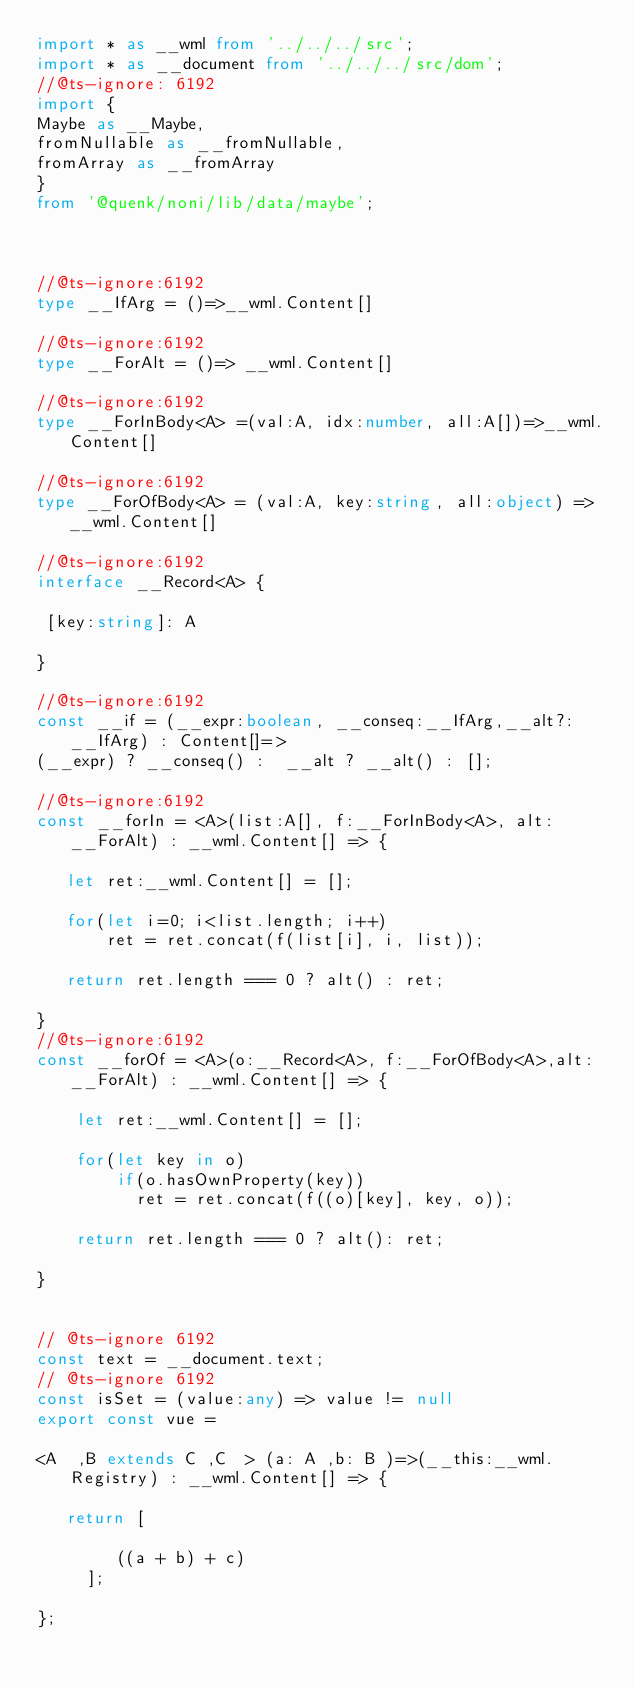Convert code to text. <code><loc_0><loc_0><loc_500><loc_500><_TypeScript_>import * as __wml from '../../../src';
import * as __document from '../../../src/dom';
//@ts-ignore: 6192
import {
Maybe as __Maybe,
fromNullable as __fromNullable,
fromArray as __fromArray
}
from '@quenk/noni/lib/data/maybe';



//@ts-ignore:6192
type __IfArg = ()=>__wml.Content[]

//@ts-ignore:6192
type __ForAlt = ()=> __wml.Content[]

//@ts-ignore:6192
type __ForInBody<A> =(val:A, idx:number, all:A[])=>__wml.Content[]

//@ts-ignore:6192
type __ForOfBody<A> = (val:A, key:string, all:object) =>__wml.Content[]

//@ts-ignore:6192
interface __Record<A> {

 [key:string]: A

}

//@ts-ignore:6192
const __if = (__expr:boolean, __conseq:__IfArg,__alt?:__IfArg) : Content[]=>
(__expr) ? __conseq() :  __alt ? __alt() : [];

//@ts-ignore:6192
const __forIn = <A>(list:A[], f:__ForInBody<A>, alt:__ForAlt) : __wml.Content[] => {

   let ret:__wml.Content[] = [];

   for(let i=0; i<list.length; i++)
       ret = ret.concat(f(list[i], i, list));

   return ret.length === 0 ? alt() : ret;

}
//@ts-ignore:6192
const __forOf = <A>(o:__Record<A>, f:__ForOfBody<A>,alt:__ForAlt) : __wml.Content[] => {

    let ret:__wml.Content[] = [];

    for(let key in o)
  	    if(o.hasOwnProperty(key)) 
	        ret = ret.concat(f((o)[key], key, o));

    return ret.length === 0 ? alt(): ret;

}


// @ts-ignore 6192
const text = __document.text;
// @ts-ignore 6192
const isSet = (value:any) => value != null
export const vue = 

<A  ,B extends C ,C  > (a: A ,b: B )=>(__this:__wml.Registry) : __wml.Content[] => {

   return [

        ((a + b) + c)
     ];

};</code> 